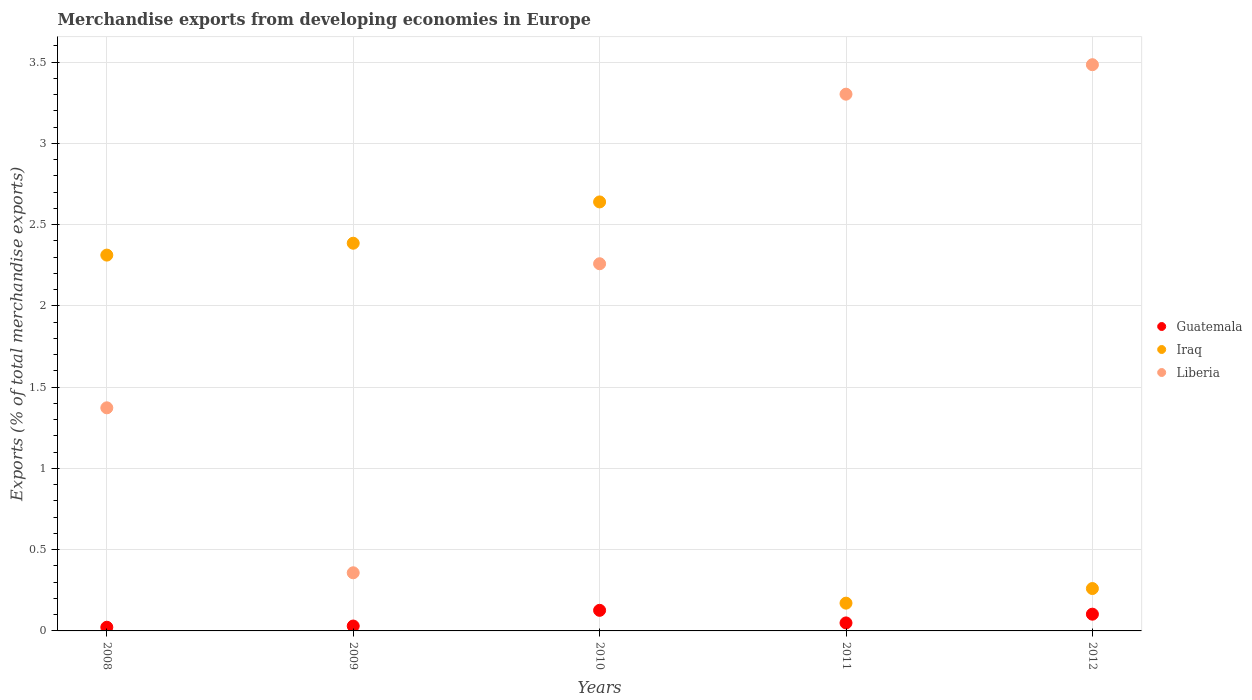What is the percentage of total merchandise exports in Liberia in 2008?
Your answer should be compact. 1.37. Across all years, what is the maximum percentage of total merchandise exports in Guatemala?
Make the answer very short. 0.13. Across all years, what is the minimum percentage of total merchandise exports in Guatemala?
Give a very brief answer. 0.02. What is the total percentage of total merchandise exports in Guatemala in the graph?
Keep it short and to the point. 0.33. What is the difference between the percentage of total merchandise exports in Guatemala in 2011 and that in 2012?
Ensure brevity in your answer.  -0.05. What is the difference between the percentage of total merchandise exports in Liberia in 2011 and the percentage of total merchandise exports in Iraq in 2010?
Your response must be concise. 0.66. What is the average percentage of total merchandise exports in Iraq per year?
Provide a short and direct response. 1.55. In the year 2008, what is the difference between the percentage of total merchandise exports in Liberia and percentage of total merchandise exports in Guatemala?
Offer a terse response. 1.35. What is the ratio of the percentage of total merchandise exports in Iraq in 2008 to that in 2010?
Make the answer very short. 0.88. What is the difference between the highest and the second highest percentage of total merchandise exports in Liberia?
Your answer should be very brief. 0.18. What is the difference between the highest and the lowest percentage of total merchandise exports in Iraq?
Your response must be concise. 2.47. Is it the case that in every year, the sum of the percentage of total merchandise exports in Guatemala and percentage of total merchandise exports in Liberia  is greater than the percentage of total merchandise exports in Iraq?
Provide a succinct answer. No. Does the percentage of total merchandise exports in Iraq monotonically increase over the years?
Offer a terse response. No. Is the percentage of total merchandise exports in Iraq strictly greater than the percentage of total merchandise exports in Liberia over the years?
Your response must be concise. No. How many dotlines are there?
Ensure brevity in your answer.  3. How many years are there in the graph?
Your answer should be compact. 5. Does the graph contain any zero values?
Provide a succinct answer. No. How are the legend labels stacked?
Provide a succinct answer. Vertical. What is the title of the graph?
Give a very brief answer. Merchandise exports from developing economies in Europe. What is the label or title of the X-axis?
Your response must be concise. Years. What is the label or title of the Y-axis?
Ensure brevity in your answer.  Exports (% of total merchandise exports). What is the Exports (% of total merchandise exports) of Guatemala in 2008?
Make the answer very short. 0.02. What is the Exports (% of total merchandise exports) in Iraq in 2008?
Provide a succinct answer. 2.31. What is the Exports (% of total merchandise exports) of Liberia in 2008?
Offer a terse response. 1.37. What is the Exports (% of total merchandise exports) in Guatemala in 2009?
Make the answer very short. 0.03. What is the Exports (% of total merchandise exports) in Iraq in 2009?
Offer a terse response. 2.39. What is the Exports (% of total merchandise exports) in Liberia in 2009?
Ensure brevity in your answer.  0.36. What is the Exports (% of total merchandise exports) of Guatemala in 2010?
Offer a terse response. 0.13. What is the Exports (% of total merchandise exports) of Iraq in 2010?
Offer a terse response. 2.64. What is the Exports (% of total merchandise exports) in Liberia in 2010?
Offer a terse response. 2.26. What is the Exports (% of total merchandise exports) of Guatemala in 2011?
Give a very brief answer. 0.05. What is the Exports (% of total merchandise exports) of Iraq in 2011?
Your response must be concise. 0.17. What is the Exports (% of total merchandise exports) of Liberia in 2011?
Offer a very short reply. 3.3. What is the Exports (% of total merchandise exports) in Guatemala in 2012?
Ensure brevity in your answer.  0.1. What is the Exports (% of total merchandise exports) of Iraq in 2012?
Provide a succinct answer. 0.26. What is the Exports (% of total merchandise exports) in Liberia in 2012?
Your response must be concise. 3.48. Across all years, what is the maximum Exports (% of total merchandise exports) in Guatemala?
Keep it short and to the point. 0.13. Across all years, what is the maximum Exports (% of total merchandise exports) of Iraq?
Provide a short and direct response. 2.64. Across all years, what is the maximum Exports (% of total merchandise exports) in Liberia?
Provide a short and direct response. 3.48. Across all years, what is the minimum Exports (% of total merchandise exports) in Guatemala?
Make the answer very short. 0.02. Across all years, what is the minimum Exports (% of total merchandise exports) in Iraq?
Give a very brief answer. 0.17. Across all years, what is the minimum Exports (% of total merchandise exports) of Liberia?
Your answer should be compact. 0.36. What is the total Exports (% of total merchandise exports) of Guatemala in the graph?
Your answer should be compact. 0.33. What is the total Exports (% of total merchandise exports) in Iraq in the graph?
Your answer should be compact. 7.77. What is the total Exports (% of total merchandise exports) in Liberia in the graph?
Your answer should be compact. 10.78. What is the difference between the Exports (% of total merchandise exports) of Guatemala in 2008 and that in 2009?
Make the answer very short. -0.01. What is the difference between the Exports (% of total merchandise exports) of Iraq in 2008 and that in 2009?
Provide a short and direct response. -0.07. What is the difference between the Exports (% of total merchandise exports) in Liberia in 2008 and that in 2009?
Your answer should be very brief. 1.02. What is the difference between the Exports (% of total merchandise exports) in Guatemala in 2008 and that in 2010?
Ensure brevity in your answer.  -0.1. What is the difference between the Exports (% of total merchandise exports) in Iraq in 2008 and that in 2010?
Ensure brevity in your answer.  -0.33. What is the difference between the Exports (% of total merchandise exports) of Liberia in 2008 and that in 2010?
Your response must be concise. -0.89. What is the difference between the Exports (% of total merchandise exports) of Guatemala in 2008 and that in 2011?
Provide a short and direct response. -0.03. What is the difference between the Exports (% of total merchandise exports) of Iraq in 2008 and that in 2011?
Offer a terse response. 2.14. What is the difference between the Exports (% of total merchandise exports) in Liberia in 2008 and that in 2011?
Ensure brevity in your answer.  -1.93. What is the difference between the Exports (% of total merchandise exports) in Guatemala in 2008 and that in 2012?
Provide a succinct answer. -0.08. What is the difference between the Exports (% of total merchandise exports) in Iraq in 2008 and that in 2012?
Provide a succinct answer. 2.05. What is the difference between the Exports (% of total merchandise exports) in Liberia in 2008 and that in 2012?
Your answer should be compact. -2.11. What is the difference between the Exports (% of total merchandise exports) in Guatemala in 2009 and that in 2010?
Your response must be concise. -0.1. What is the difference between the Exports (% of total merchandise exports) in Iraq in 2009 and that in 2010?
Make the answer very short. -0.25. What is the difference between the Exports (% of total merchandise exports) in Liberia in 2009 and that in 2010?
Your answer should be very brief. -1.9. What is the difference between the Exports (% of total merchandise exports) in Guatemala in 2009 and that in 2011?
Provide a short and direct response. -0.02. What is the difference between the Exports (% of total merchandise exports) of Iraq in 2009 and that in 2011?
Give a very brief answer. 2.22. What is the difference between the Exports (% of total merchandise exports) of Liberia in 2009 and that in 2011?
Ensure brevity in your answer.  -2.95. What is the difference between the Exports (% of total merchandise exports) in Guatemala in 2009 and that in 2012?
Your response must be concise. -0.07. What is the difference between the Exports (% of total merchandise exports) of Iraq in 2009 and that in 2012?
Provide a succinct answer. 2.13. What is the difference between the Exports (% of total merchandise exports) in Liberia in 2009 and that in 2012?
Offer a very short reply. -3.13. What is the difference between the Exports (% of total merchandise exports) in Guatemala in 2010 and that in 2011?
Provide a short and direct response. 0.08. What is the difference between the Exports (% of total merchandise exports) in Iraq in 2010 and that in 2011?
Give a very brief answer. 2.47. What is the difference between the Exports (% of total merchandise exports) in Liberia in 2010 and that in 2011?
Keep it short and to the point. -1.04. What is the difference between the Exports (% of total merchandise exports) in Guatemala in 2010 and that in 2012?
Provide a short and direct response. 0.02. What is the difference between the Exports (% of total merchandise exports) in Iraq in 2010 and that in 2012?
Offer a very short reply. 2.38. What is the difference between the Exports (% of total merchandise exports) in Liberia in 2010 and that in 2012?
Offer a terse response. -1.23. What is the difference between the Exports (% of total merchandise exports) in Guatemala in 2011 and that in 2012?
Make the answer very short. -0.05. What is the difference between the Exports (% of total merchandise exports) in Iraq in 2011 and that in 2012?
Your response must be concise. -0.09. What is the difference between the Exports (% of total merchandise exports) of Liberia in 2011 and that in 2012?
Keep it short and to the point. -0.18. What is the difference between the Exports (% of total merchandise exports) of Guatemala in 2008 and the Exports (% of total merchandise exports) of Iraq in 2009?
Provide a succinct answer. -2.36. What is the difference between the Exports (% of total merchandise exports) in Guatemala in 2008 and the Exports (% of total merchandise exports) in Liberia in 2009?
Your response must be concise. -0.34. What is the difference between the Exports (% of total merchandise exports) in Iraq in 2008 and the Exports (% of total merchandise exports) in Liberia in 2009?
Provide a succinct answer. 1.96. What is the difference between the Exports (% of total merchandise exports) of Guatemala in 2008 and the Exports (% of total merchandise exports) of Iraq in 2010?
Your answer should be compact. -2.62. What is the difference between the Exports (% of total merchandise exports) of Guatemala in 2008 and the Exports (% of total merchandise exports) of Liberia in 2010?
Give a very brief answer. -2.24. What is the difference between the Exports (% of total merchandise exports) in Iraq in 2008 and the Exports (% of total merchandise exports) in Liberia in 2010?
Your answer should be very brief. 0.05. What is the difference between the Exports (% of total merchandise exports) in Guatemala in 2008 and the Exports (% of total merchandise exports) in Iraq in 2011?
Make the answer very short. -0.15. What is the difference between the Exports (% of total merchandise exports) in Guatemala in 2008 and the Exports (% of total merchandise exports) in Liberia in 2011?
Keep it short and to the point. -3.28. What is the difference between the Exports (% of total merchandise exports) in Iraq in 2008 and the Exports (% of total merchandise exports) in Liberia in 2011?
Keep it short and to the point. -0.99. What is the difference between the Exports (% of total merchandise exports) of Guatemala in 2008 and the Exports (% of total merchandise exports) of Iraq in 2012?
Give a very brief answer. -0.24. What is the difference between the Exports (% of total merchandise exports) of Guatemala in 2008 and the Exports (% of total merchandise exports) of Liberia in 2012?
Ensure brevity in your answer.  -3.46. What is the difference between the Exports (% of total merchandise exports) in Iraq in 2008 and the Exports (% of total merchandise exports) in Liberia in 2012?
Your answer should be very brief. -1.17. What is the difference between the Exports (% of total merchandise exports) of Guatemala in 2009 and the Exports (% of total merchandise exports) of Iraq in 2010?
Offer a terse response. -2.61. What is the difference between the Exports (% of total merchandise exports) in Guatemala in 2009 and the Exports (% of total merchandise exports) in Liberia in 2010?
Give a very brief answer. -2.23. What is the difference between the Exports (% of total merchandise exports) of Iraq in 2009 and the Exports (% of total merchandise exports) of Liberia in 2010?
Offer a terse response. 0.13. What is the difference between the Exports (% of total merchandise exports) of Guatemala in 2009 and the Exports (% of total merchandise exports) of Iraq in 2011?
Provide a succinct answer. -0.14. What is the difference between the Exports (% of total merchandise exports) of Guatemala in 2009 and the Exports (% of total merchandise exports) of Liberia in 2011?
Your response must be concise. -3.27. What is the difference between the Exports (% of total merchandise exports) in Iraq in 2009 and the Exports (% of total merchandise exports) in Liberia in 2011?
Your answer should be very brief. -0.92. What is the difference between the Exports (% of total merchandise exports) in Guatemala in 2009 and the Exports (% of total merchandise exports) in Iraq in 2012?
Give a very brief answer. -0.23. What is the difference between the Exports (% of total merchandise exports) of Guatemala in 2009 and the Exports (% of total merchandise exports) of Liberia in 2012?
Your answer should be very brief. -3.45. What is the difference between the Exports (% of total merchandise exports) in Iraq in 2009 and the Exports (% of total merchandise exports) in Liberia in 2012?
Ensure brevity in your answer.  -1.1. What is the difference between the Exports (% of total merchandise exports) of Guatemala in 2010 and the Exports (% of total merchandise exports) of Iraq in 2011?
Provide a short and direct response. -0.04. What is the difference between the Exports (% of total merchandise exports) of Guatemala in 2010 and the Exports (% of total merchandise exports) of Liberia in 2011?
Keep it short and to the point. -3.18. What is the difference between the Exports (% of total merchandise exports) of Iraq in 2010 and the Exports (% of total merchandise exports) of Liberia in 2011?
Offer a terse response. -0.66. What is the difference between the Exports (% of total merchandise exports) in Guatemala in 2010 and the Exports (% of total merchandise exports) in Iraq in 2012?
Offer a terse response. -0.13. What is the difference between the Exports (% of total merchandise exports) of Guatemala in 2010 and the Exports (% of total merchandise exports) of Liberia in 2012?
Your answer should be compact. -3.36. What is the difference between the Exports (% of total merchandise exports) in Iraq in 2010 and the Exports (% of total merchandise exports) in Liberia in 2012?
Give a very brief answer. -0.84. What is the difference between the Exports (% of total merchandise exports) of Guatemala in 2011 and the Exports (% of total merchandise exports) of Iraq in 2012?
Offer a very short reply. -0.21. What is the difference between the Exports (% of total merchandise exports) in Guatemala in 2011 and the Exports (% of total merchandise exports) in Liberia in 2012?
Give a very brief answer. -3.44. What is the difference between the Exports (% of total merchandise exports) in Iraq in 2011 and the Exports (% of total merchandise exports) in Liberia in 2012?
Offer a very short reply. -3.31. What is the average Exports (% of total merchandise exports) of Guatemala per year?
Provide a short and direct response. 0.07. What is the average Exports (% of total merchandise exports) of Iraq per year?
Your answer should be compact. 1.55. What is the average Exports (% of total merchandise exports) in Liberia per year?
Your answer should be compact. 2.16. In the year 2008, what is the difference between the Exports (% of total merchandise exports) in Guatemala and Exports (% of total merchandise exports) in Iraq?
Offer a very short reply. -2.29. In the year 2008, what is the difference between the Exports (% of total merchandise exports) in Guatemala and Exports (% of total merchandise exports) in Liberia?
Keep it short and to the point. -1.35. In the year 2008, what is the difference between the Exports (% of total merchandise exports) in Iraq and Exports (% of total merchandise exports) in Liberia?
Provide a succinct answer. 0.94. In the year 2009, what is the difference between the Exports (% of total merchandise exports) of Guatemala and Exports (% of total merchandise exports) of Iraq?
Your response must be concise. -2.36. In the year 2009, what is the difference between the Exports (% of total merchandise exports) of Guatemala and Exports (% of total merchandise exports) of Liberia?
Provide a short and direct response. -0.33. In the year 2009, what is the difference between the Exports (% of total merchandise exports) of Iraq and Exports (% of total merchandise exports) of Liberia?
Offer a terse response. 2.03. In the year 2010, what is the difference between the Exports (% of total merchandise exports) in Guatemala and Exports (% of total merchandise exports) in Iraq?
Your response must be concise. -2.51. In the year 2010, what is the difference between the Exports (% of total merchandise exports) of Guatemala and Exports (% of total merchandise exports) of Liberia?
Provide a succinct answer. -2.13. In the year 2010, what is the difference between the Exports (% of total merchandise exports) of Iraq and Exports (% of total merchandise exports) of Liberia?
Provide a succinct answer. 0.38. In the year 2011, what is the difference between the Exports (% of total merchandise exports) in Guatemala and Exports (% of total merchandise exports) in Iraq?
Make the answer very short. -0.12. In the year 2011, what is the difference between the Exports (% of total merchandise exports) of Guatemala and Exports (% of total merchandise exports) of Liberia?
Offer a very short reply. -3.25. In the year 2011, what is the difference between the Exports (% of total merchandise exports) in Iraq and Exports (% of total merchandise exports) in Liberia?
Make the answer very short. -3.13. In the year 2012, what is the difference between the Exports (% of total merchandise exports) in Guatemala and Exports (% of total merchandise exports) in Iraq?
Your answer should be very brief. -0.16. In the year 2012, what is the difference between the Exports (% of total merchandise exports) in Guatemala and Exports (% of total merchandise exports) in Liberia?
Ensure brevity in your answer.  -3.38. In the year 2012, what is the difference between the Exports (% of total merchandise exports) in Iraq and Exports (% of total merchandise exports) in Liberia?
Provide a succinct answer. -3.22. What is the ratio of the Exports (% of total merchandise exports) of Guatemala in 2008 to that in 2009?
Your answer should be compact. 0.75. What is the ratio of the Exports (% of total merchandise exports) of Iraq in 2008 to that in 2009?
Your answer should be very brief. 0.97. What is the ratio of the Exports (% of total merchandise exports) in Liberia in 2008 to that in 2009?
Keep it short and to the point. 3.84. What is the ratio of the Exports (% of total merchandise exports) of Guatemala in 2008 to that in 2010?
Provide a short and direct response. 0.18. What is the ratio of the Exports (% of total merchandise exports) of Iraq in 2008 to that in 2010?
Your response must be concise. 0.88. What is the ratio of the Exports (% of total merchandise exports) in Liberia in 2008 to that in 2010?
Provide a short and direct response. 0.61. What is the ratio of the Exports (% of total merchandise exports) of Guatemala in 2008 to that in 2011?
Ensure brevity in your answer.  0.46. What is the ratio of the Exports (% of total merchandise exports) of Iraq in 2008 to that in 2011?
Your answer should be very brief. 13.54. What is the ratio of the Exports (% of total merchandise exports) of Liberia in 2008 to that in 2011?
Your response must be concise. 0.42. What is the ratio of the Exports (% of total merchandise exports) in Guatemala in 2008 to that in 2012?
Your response must be concise. 0.22. What is the ratio of the Exports (% of total merchandise exports) in Iraq in 2008 to that in 2012?
Make the answer very short. 8.87. What is the ratio of the Exports (% of total merchandise exports) of Liberia in 2008 to that in 2012?
Provide a short and direct response. 0.39. What is the ratio of the Exports (% of total merchandise exports) of Guatemala in 2009 to that in 2010?
Give a very brief answer. 0.24. What is the ratio of the Exports (% of total merchandise exports) of Iraq in 2009 to that in 2010?
Make the answer very short. 0.9. What is the ratio of the Exports (% of total merchandise exports) of Liberia in 2009 to that in 2010?
Your answer should be compact. 0.16. What is the ratio of the Exports (% of total merchandise exports) in Guatemala in 2009 to that in 2011?
Keep it short and to the point. 0.61. What is the ratio of the Exports (% of total merchandise exports) of Iraq in 2009 to that in 2011?
Your answer should be very brief. 13.96. What is the ratio of the Exports (% of total merchandise exports) in Liberia in 2009 to that in 2011?
Keep it short and to the point. 0.11. What is the ratio of the Exports (% of total merchandise exports) of Guatemala in 2009 to that in 2012?
Provide a succinct answer. 0.29. What is the ratio of the Exports (% of total merchandise exports) in Iraq in 2009 to that in 2012?
Provide a succinct answer. 9.15. What is the ratio of the Exports (% of total merchandise exports) of Liberia in 2009 to that in 2012?
Your answer should be very brief. 0.1. What is the ratio of the Exports (% of total merchandise exports) in Guatemala in 2010 to that in 2011?
Your answer should be compact. 2.57. What is the ratio of the Exports (% of total merchandise exports) of Iraq in 2010 to that in 2011?
Offer a terse response. 15.45. What is the ratio of the Exports (% of total merchandise exports) in Liberia in 2010 to that in 2011?
Your response must be concise. 0.68. What is the ratio of the Exports (% of total merchandise exports) in Guatemala in 2010 to that in 2012?
Ensure brevity in your answer.  1.23. What is the ratio of the Exports (% of total merchandise exports) of Iraq in 2010 to that in 2012?
Keep it short and to the point. 10.12. What is the ratio of the Exports (% of total merchandise exports) in Liberia in 2010 to that in 2012?
Your answer should be compact. 0.65. What is the ratio of the Exports (% of total merchandise exports) in Guatemala in 2011 to that in 2012?
Make the answer very short. 0.48. What is the ratio of the Exports (% of total merchandise exports) in Iraq in 2011 to that in 2012?
Your answer should be very brief. 0.66. What is the ratio of the Exports (% of total merchandise exports) in Liberia in 2011 to that in 2012?
Give a very brief answer. 0.95. What is the difference between the highest and the second highest Exports (% of total merchandise exports) of Guatemala?
Your answer should be very brief. 0.02. What is the difference between the highest and the second highest Exports (% of total merchandise exports) of Iraq?
Provide a succinct answer. 0.25. What is the difference between the highest and the second highest Exports (% of total merchandise exports) of Liberia?
Your answer should be compact. 0.18. What is the difference between the highest and the lowest Exports (% of total merchandise exports) in Guatemala?
Give a very brief answer. 0.1. What is the difference between the highest and the lowest Exports (% of total merchandise exports) in Iraq?
Your response must be concise. 2.47. What is the difference between the highest and the lowest Exports (% of total merchandise exports) in Liberia?
Make the answer very short. 3.13. 